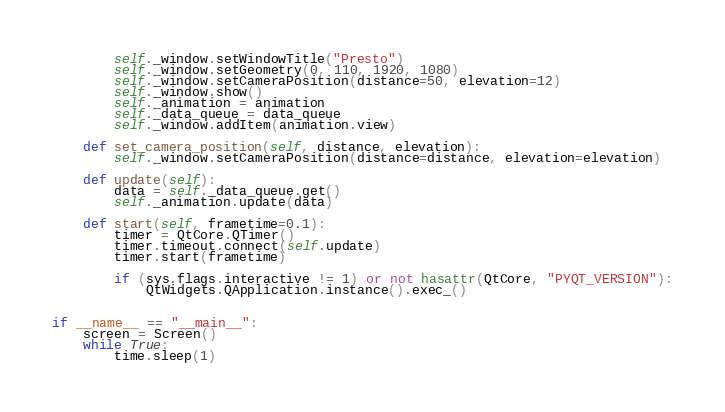<code> <loc_0><loc_0><loc_500><loc_500><_Python_>        self._window.setWindowTitle("Presto")
        self._window.setGeometry(0, 110, 1920, 1080)
        self._window.setCameraPosition(distance=50, elevation=12)
        self._window.show()
        self._animation = animation
        self._data_queue = data_queue
        self._window.addItem(animation.view)

    def set_camera_position(self, distance, elevation):
        self._window.setCameraPosition(distance=distance, elevation=elevation)

    def update(self):
        data = self._data_queue.get()
        self._animation.update(data)

    def start(self, frametime=0.1):
        timer = QtCore.QTimer()
        timer.timeout.connect(self.update)
        timer.start(frametime)

        if (sys.flags.interactive != 1) or not hasattr(QtCore, "PYQT_VERSION"):
            QtWidgets.QApplication.instance().exec_()


if __name__ == "__main__":
    screen = Screen()
    while True:
        time.sleep(1)
</code> 